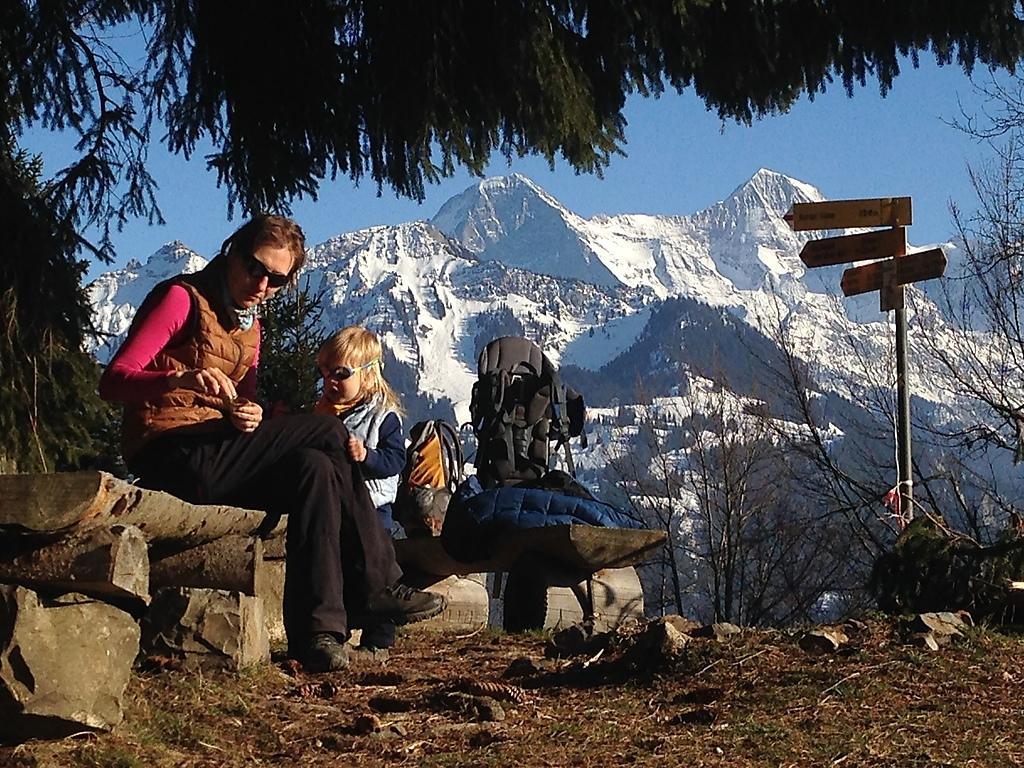In one or two sentences, can you explain what this image depicts? In this image I can see a woman wearing pink, brown and black colored dress is sitting on a bench. I can see a child and few bags on the bench. In the background I can see few trees, a pole and few boards attached to the pole, few mountains with snow on them and the sky. 